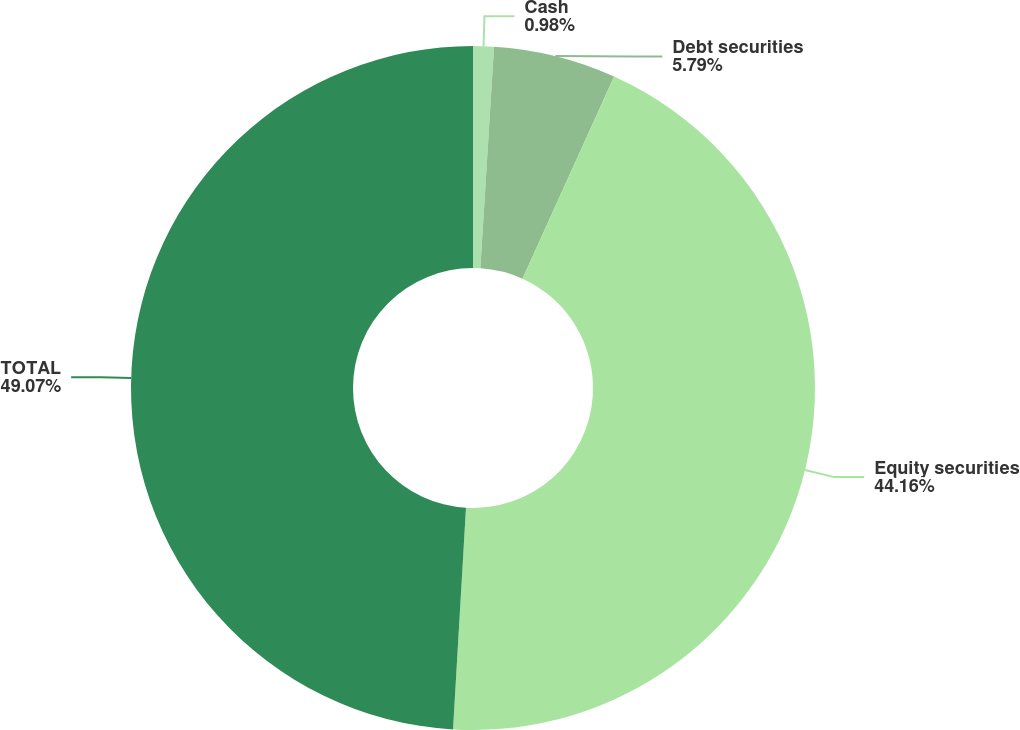Convert chart. <chart><loc_0><loc_0><loc_500><loc_500><pie_chart><fcel>Cash<fcel>Debt securities<fcel>Equity securities<fcel>TOTAL<nl><fcel>0.98%<fcel>5.79%<fcel>44.16%<fcel>49.07%<nl></chart> 